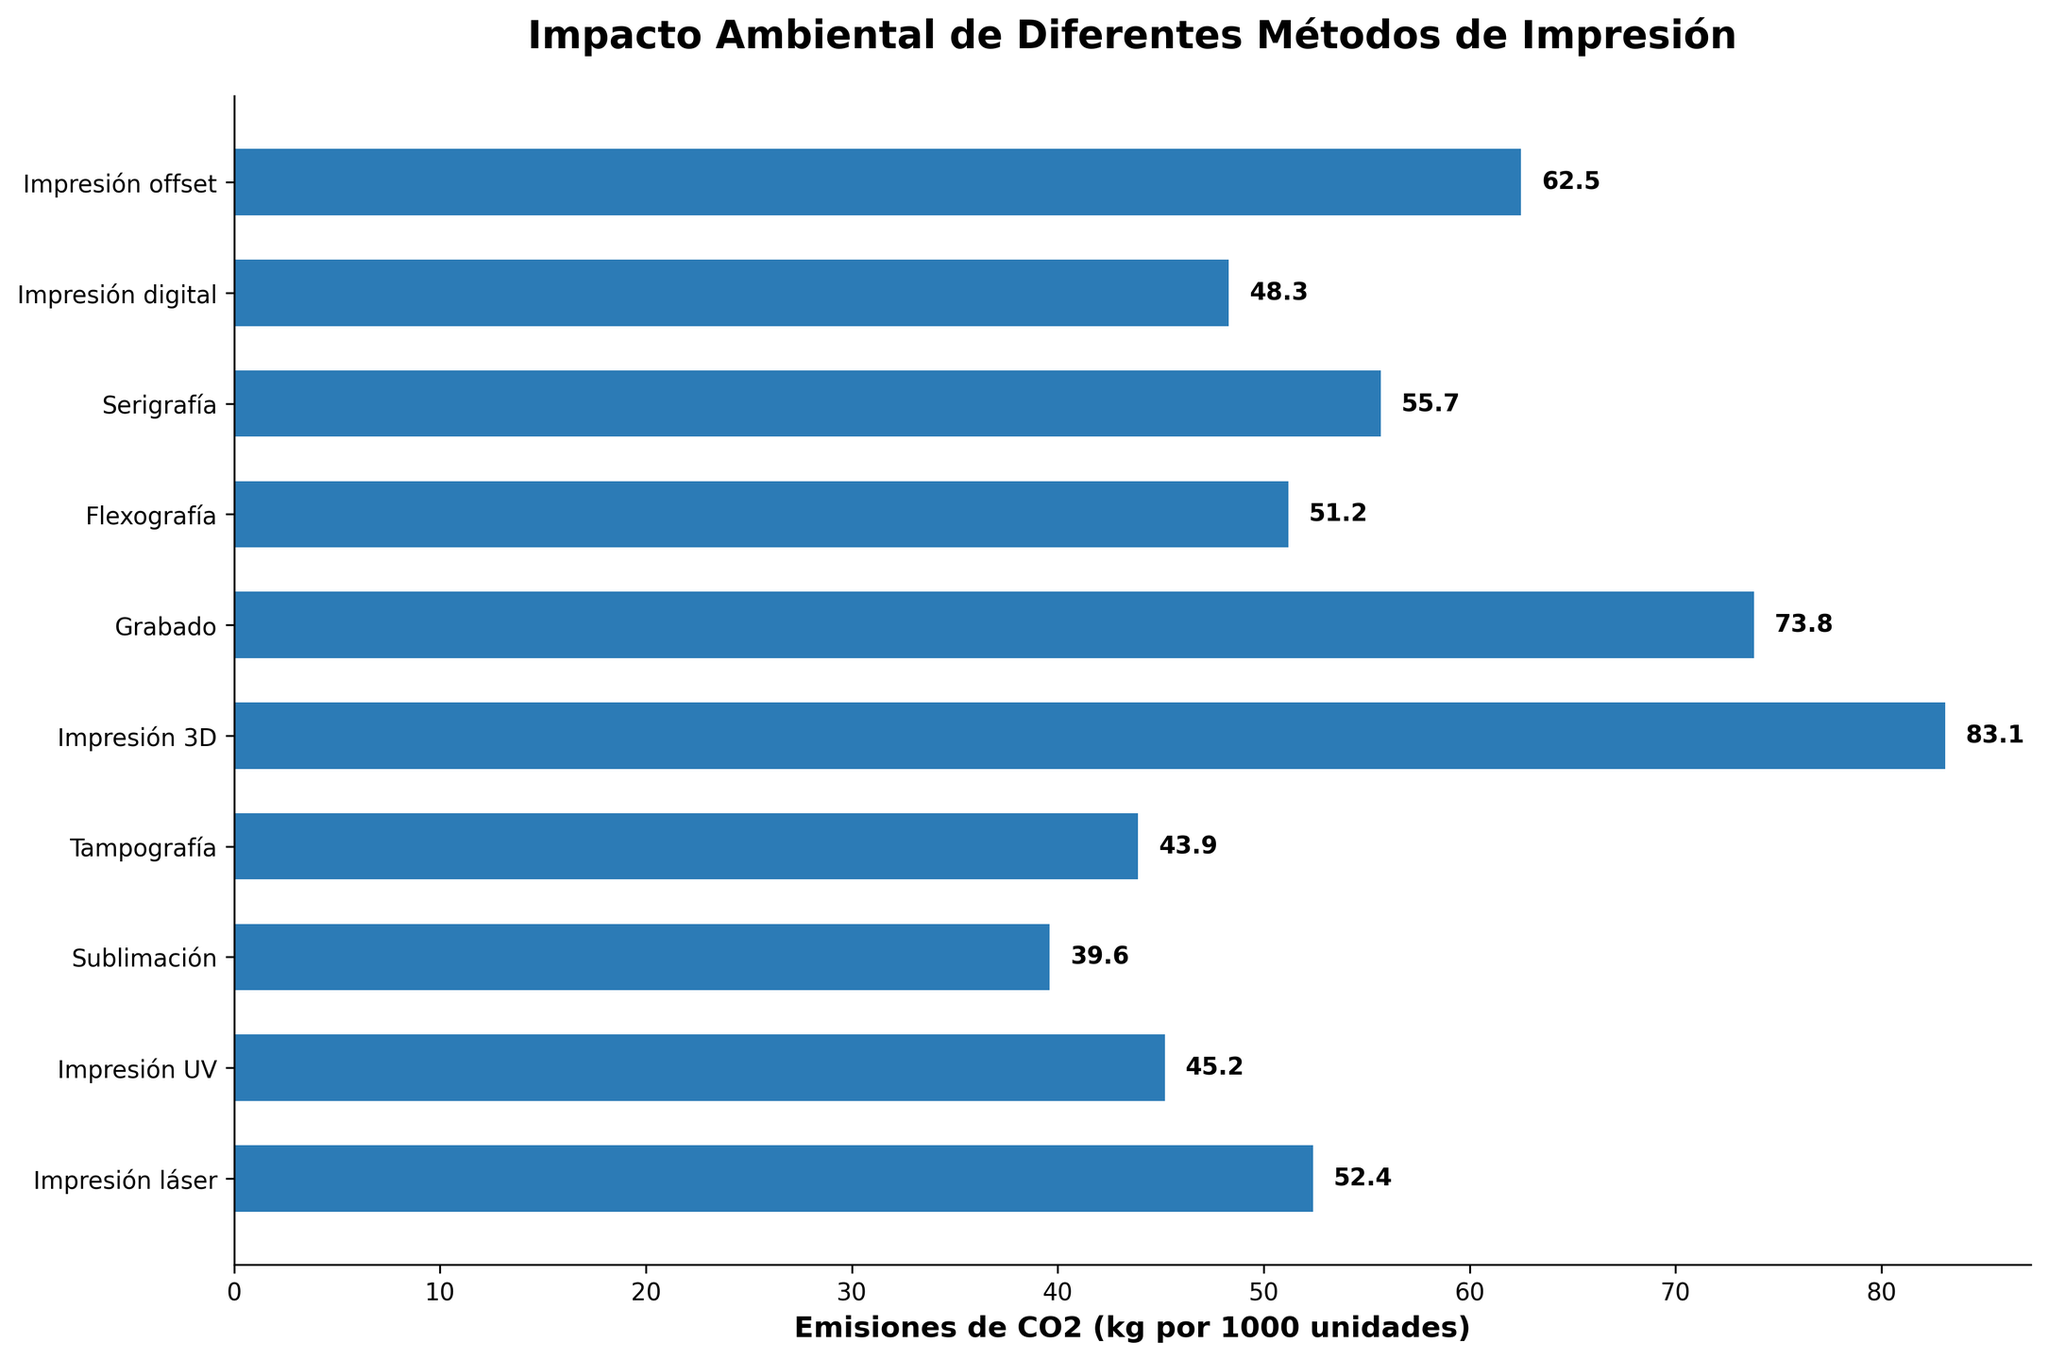What's the method with the highest CO2 emissions? Look at the bar representing the highest value. The bar for "Impresión 3D" is the longest, indicating the highest emissions.
Answer: Impresión 3D What's the method with the lowest CO2 emissions? Look for the shortest bar in the chart. The bar for "Sublimación" is the shortest, indicating the lowest emissions.
Answer: Sublimación Which methods have CO2 emissions higher than 60 kg per 1000 units? Identify bars with lengths extending beyond the 60 kg mark. The bars for "Grabado," "Impresión 3D," and "Impresión offset" extend beyond this mark.
Answer: Grabado, Impresión 3D, Impresión offset What is the difference in CO2 emissions between the highest and lowest methods? Subtract the emissions value of the method with the lowest emissions from that of the method with the highest emissions. This is 83.1 kg (Impresión 3D) - 39.6 kg (Sublimación).
Answer: 43.5 kg Which methods have CO2 emissions between 40 kg and 50 kg per 1000 units? Look for bars with lengths corresponding to values within this range. These methods are "Tampografía," "Sublimación," "Impresión UV," and "Impresión digital."
Answer: Tampografía, Sublimación, Impresión UV, Impresión digital What is the average CO2 emissions for all the methods? Sum the emissions of all methods and divide by the number of methods (62.5 + 48.3 + 55.7 + 51.2 + 73.8 + 83.1 + 43.9 + 39.6 + 45.2 + 52.4). Then, divide by 10.
Answer: 55.57 kg How many methods have emissions lower than 50 kg per 1000 units? Count the bars with lengths corresponding to values below 50 kg. These methods are "Impresión digital," "Tampografía," "Sublimación," and "Impresión UV."
Answer: 4 Which method has the closest emissions value to the average? First, calculate the average. Then, compare each method's emission to the average (55.57 kg), "Impresión láser" at 52.4 kg is the closest to this value.
Answer: Impresión láser Which method has greater emissions, "Impresión láser" or "Serigrafía"? Compare lengths of the bars for "Impresión láser" and "Serigrafía." The bar for "Serigrafía" is longer than the one for "Impresión láser."
Answer: Serigrafía What are the total CO2 emissions for "Impresión offset" and "Flexografía"? Add the emissions values of these two methods: 62.5 kg + 51.2 kg.
Answer: 113.7 kg 